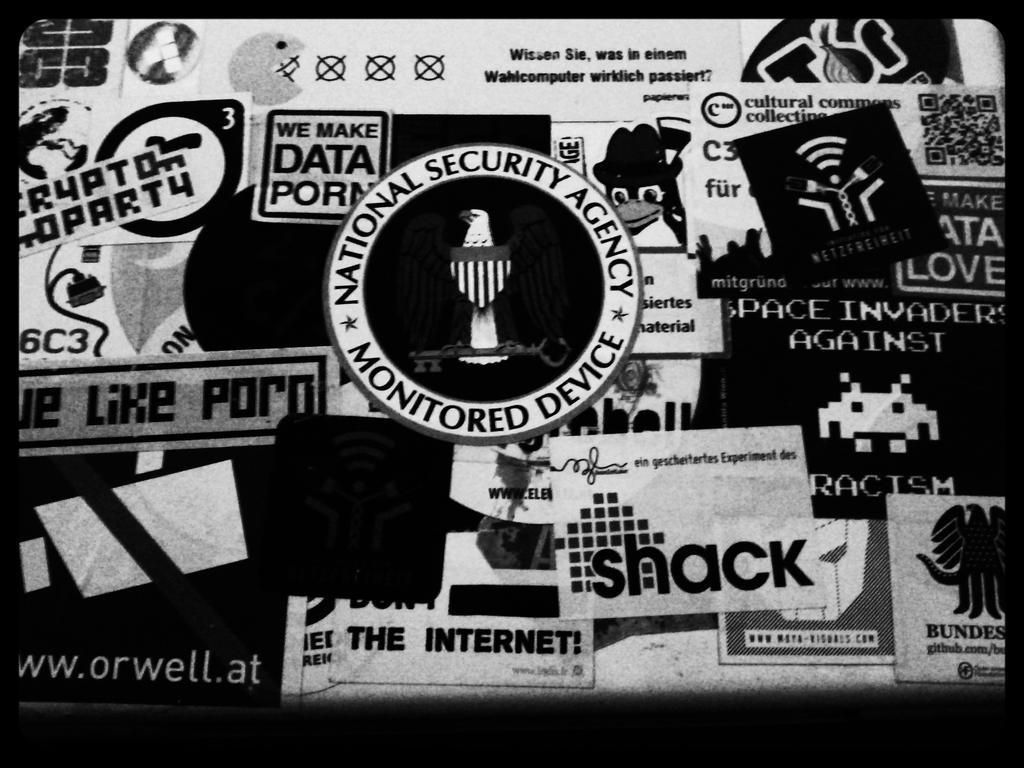Describe this image in one or two sentences. In this picture, it is looking like a poster. I can observe some text in this poster. There is a symbol in the middle of the picture. This is a black and white image. 